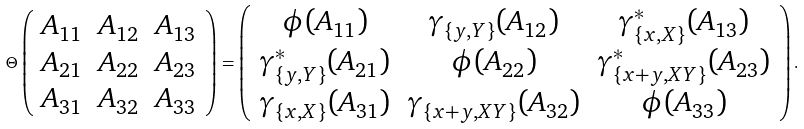<formula> <loc_0><loc_0><loc_500><loc_500>\Theta \left ( \begin{array} { c c c } A _ { 1 1 } & A _ { 1 2 } & A _ { 1 3 } \\ A _ { 2 1 } & A _ { 2 2 } & A _ { 2 3 } \\ A _ { 3 1 } & A _ { 3 2 } & A _ { 3 3 } \end{array} \right ) = \left ( \begin{array} { c c c } \phi ( A _ { 1 1 } ) & \gamma _ { \{ y , Y \} } ( A _ { 1 2 } ) & \gamma _ { \{ x , X \} } ^ { * } ( A _ { 1 3 } ) \\ \gamma _ { \{ y , Y \} } ^ { * } ( A _ { 2 1 } ) & \phi ( A _ { 2 2 } ) & \gamma _ { \{ x + y , X Y \} } ^ { * } ( A _ { 2 3 } ) \\ \gamma _ { \{ x , X \} } ( A _ { 3 1 } ) & \gamma _ { \{ x + y , X Y \} } ( A _ { 3 2 } ) & \phi ( A _ { 3 3 } ) \end{array} \right ) .</formula> 